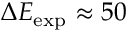<formula> <loc_0><loc_0><loc_500><loc_500>\Delta E _ { e x p } \approx 5 0</formula> 